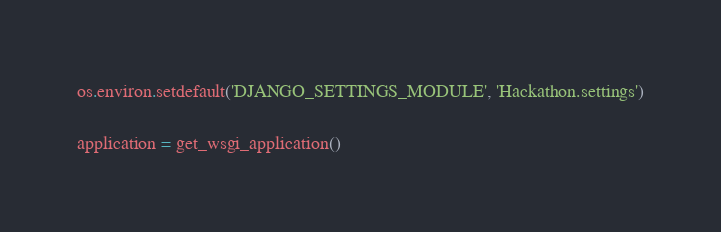Convert code to text. <code><loc_0><loc_0><loc_500><loc_500><_Python_>os.environ.setdefault('DJANGO_SETTINGS_MODULE', 'Hackathon.settings')

application = get_wsgi_application()
</code> 